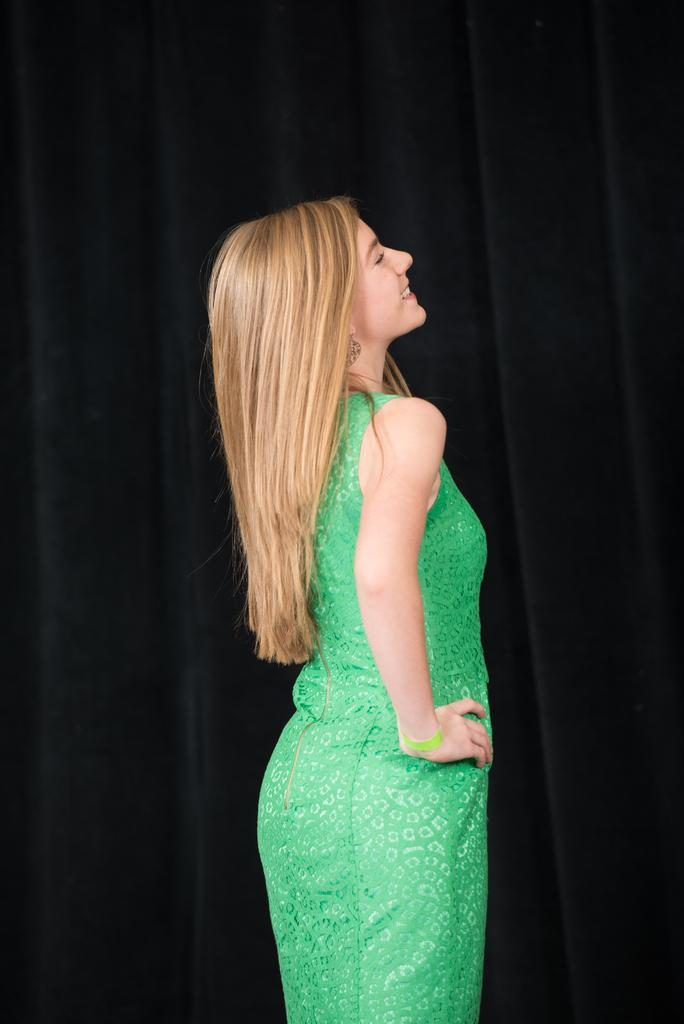Who is present in the image? There is a woman in the image. What is the woman doing in the image? The woman is smiling in the image. What can be observed about the background of the image? The background of the image is dark. How many bikes are visible in the image? There are no bikes present in the image. What type of store can be seen in the background of the image? There is no store visible in the image, as the background is dark. 